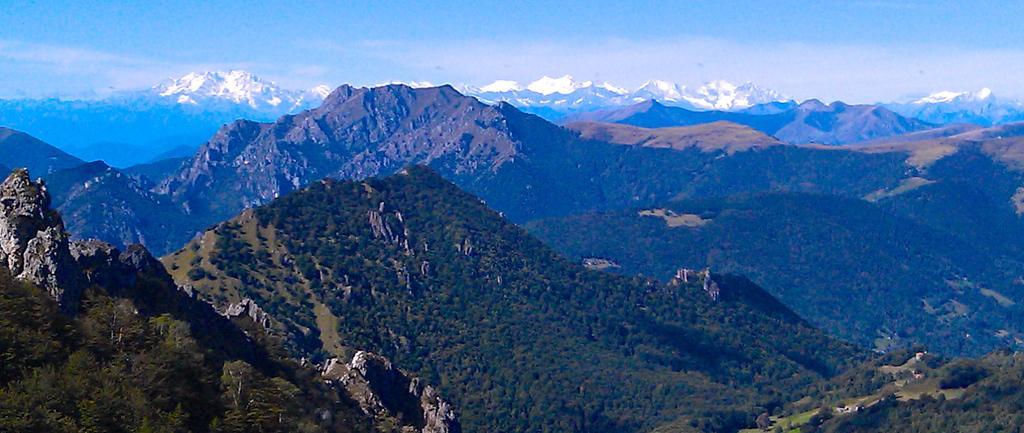Please provide a concise description of this image. In this image we can see mountains. At the top there is sky. 